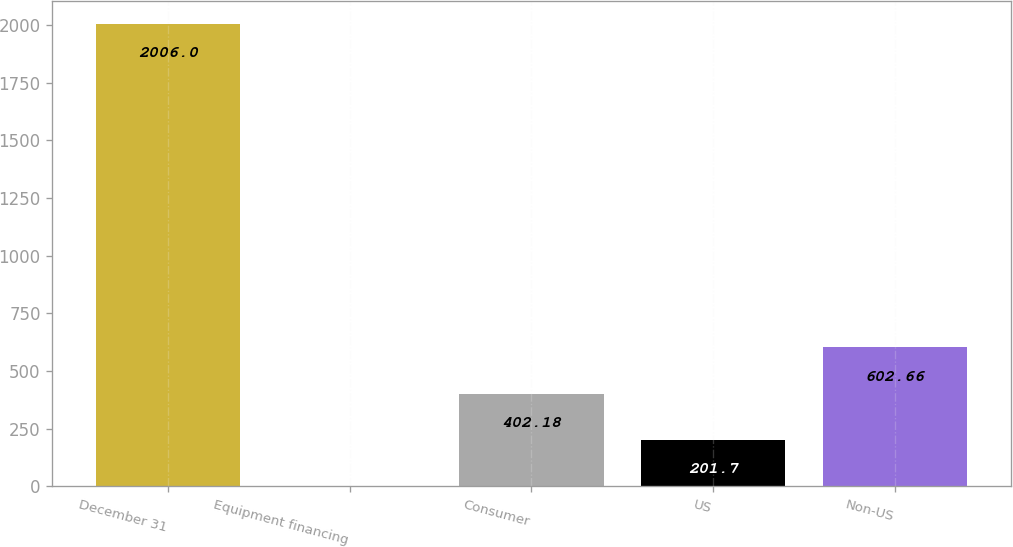<chart> <loc_0><loc_0><loc_500><loc_500><bar_chart><fcel>December 31<fcel>Equipment financing<fcel>Consumer<fcel>US<fcel>Non-US<nl><fcel>2006<fcel>1.22<fcel>402.18<fcel>201.7<fcel>602.66<nl></chart> 